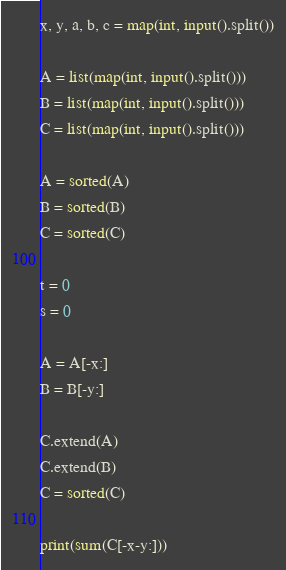<code> <loc_0><loc_0><loc_500><loc_500><_Python_>x, y, a, b, c = map(int, input().split())

A = list(map(int, input().split()))
B = list(map(int, input().split()))
C = list(map(int, input().split()))

A = sorted(A)
B = sorted(B)
C = sorted(C)

t = 0
s = 0

A = A[-x:]
B = B[-y:]

C.extend(A)
C.extend(B)
C = sorted(C)

print(sum(C[-x-y:]))</code> 